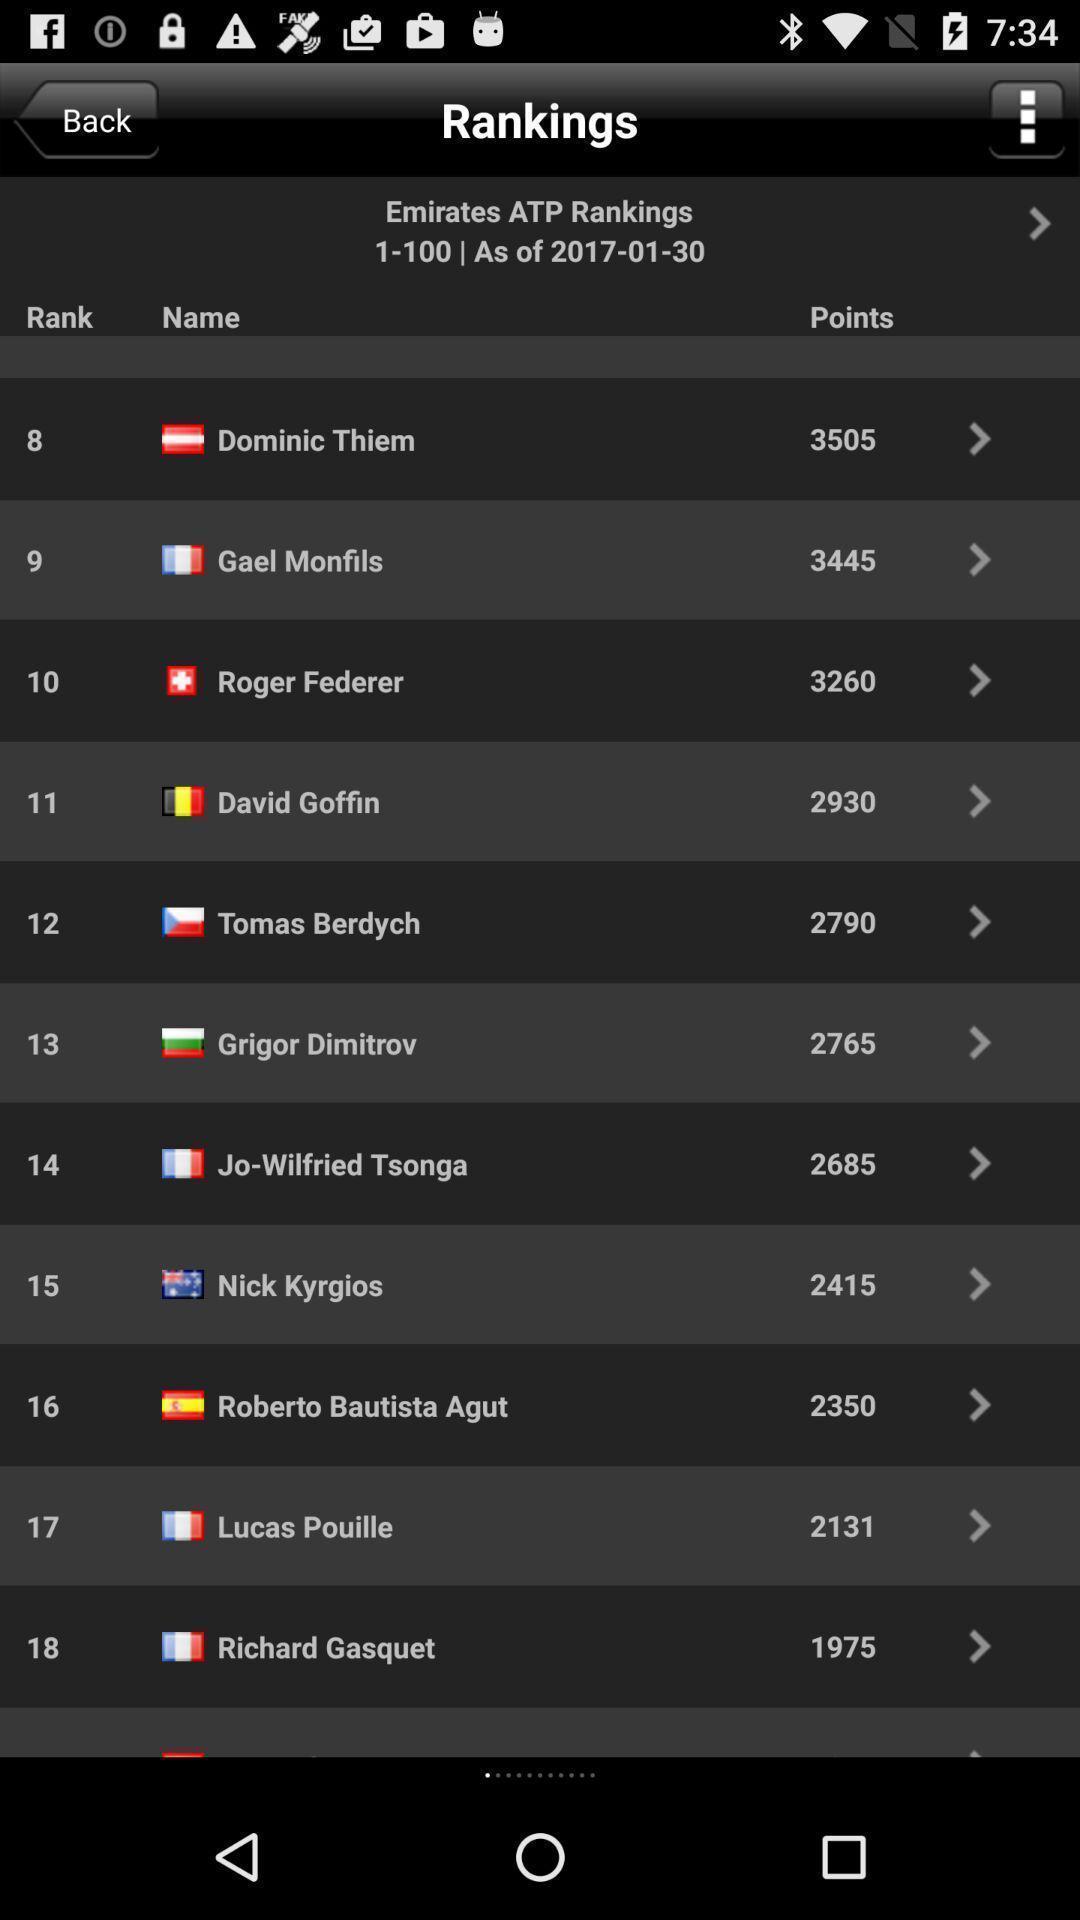Give me a narrative description of this picture. Page displaying the rankings of players. 